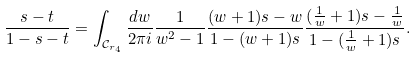<formula> <loc_0><loc_0><loc_500><loc_500>\frac { s - t } { 1 - s - t } = \int _ { \mathcal { C } _ { r _ { 4 } } } \frac { d w } { 2 \pi i } \frac { 1 } { w ^ { 2 } - 1 } \frac { ( w + 1 ) s - w } { 1 - ( w + 1 ) s } \frac { ( \frac { 1 } { w } + 1 ) s - \frac { 1 } { w } } { 1 - ( \frac { 1 } { w } + 1 ) s } .</formula> 